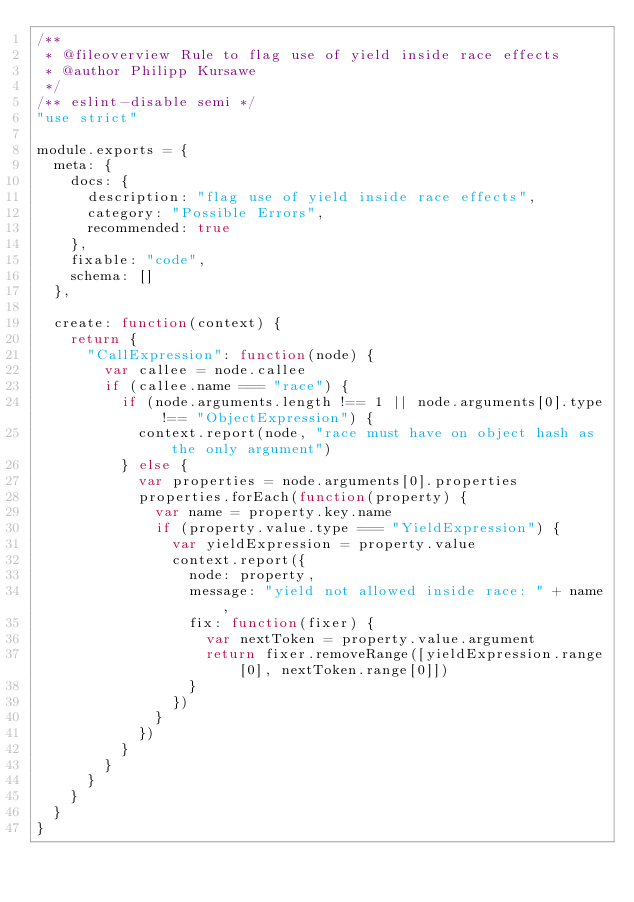<code> <loc_0><loc_0><loc_500><loc_500><_JavaScript_>/**
 * @fileoverview Rule to flag use of yield inside race effects
 * @author Philipp Kursawe
 */
/** eslint-disable semi */
"use strict"

module.exports = {
  meta: {
    docs: {
      description: "flag use of yield inside race effects",
      category: "Possible Errors",
      recommended: true
    },
    fixable: "code",
    schema: []
  },

  create: function(context) {
    return {
      "CallExpression": function(node) {
        var callee = node.callee
        if (callee.name === "race") {
          if (node.arguments.length !== 1 || node.arguments[0].type !== "ObjectExpression") {
            context.report(node, "race must have on object hash as the only argument")
          } else {
            var properties = node.arguments[0].properties
            properties.forEach(function(property) {
              var name = property.key.name
              if (property.value.type === "YieldExpression") {
                var yieldExpression = property.value
                context.report({
                  node: property,
                  message: "yield not allowed inside race: " + name,
                  fix: function(fixer) {
                    var nextToken = property.value.argument
                    return fixer.removeRange([yieldExpression.range[0], nextToken.range[0]])
                  }
                })
              }
            })
          }
        }
      }
    }
  }
}
</code> 